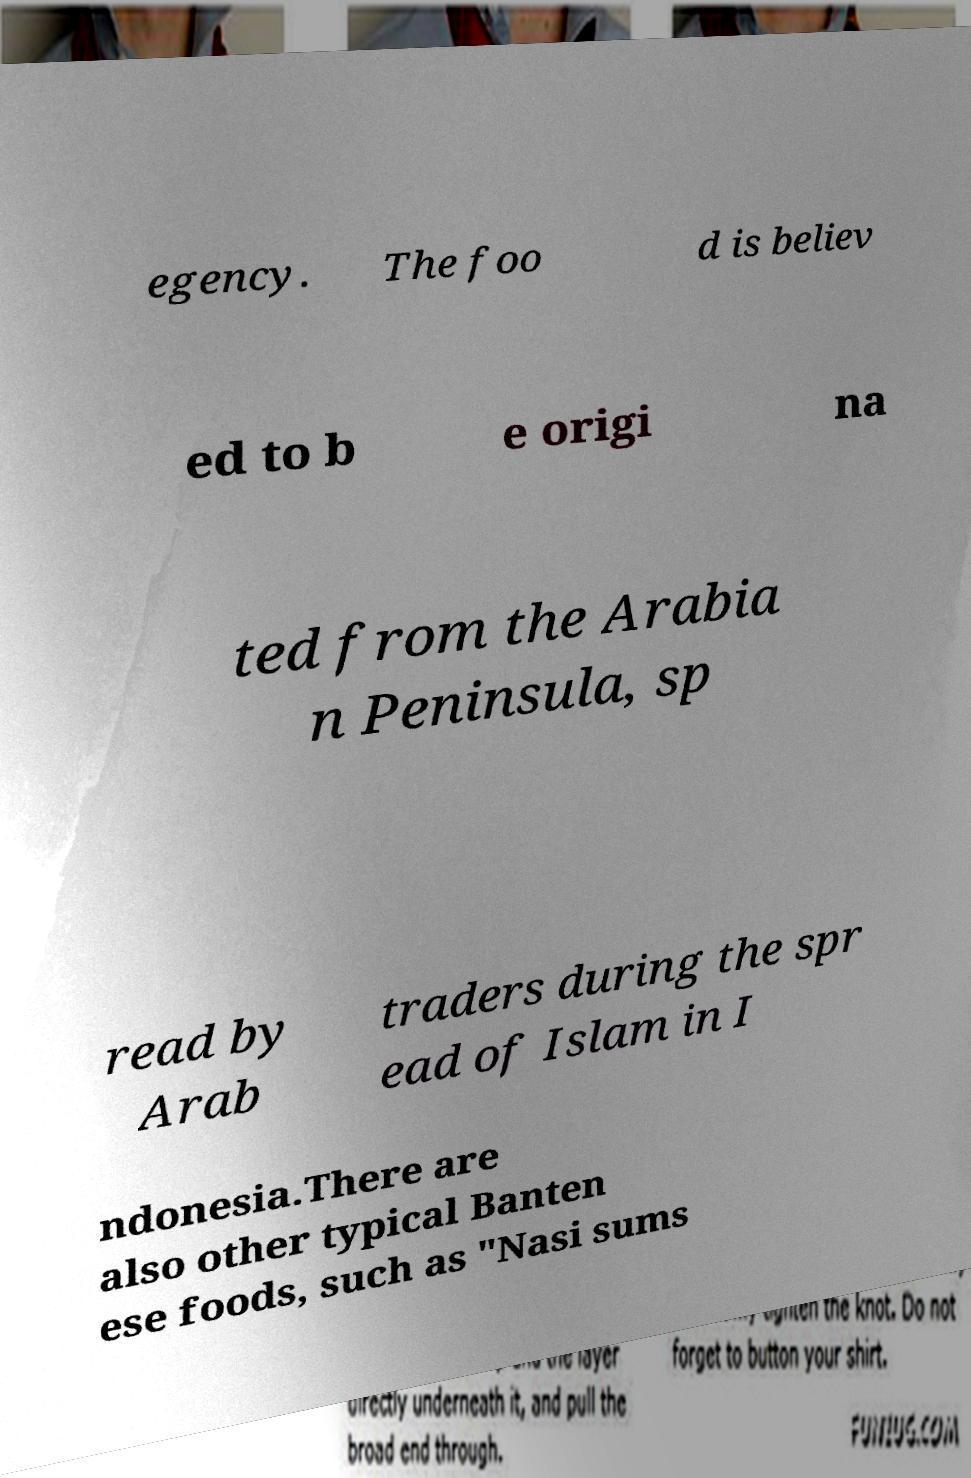Could you extract and type out the text from this image? egency. The foo d is believ ed to b e origi na ted from the Arabia n Peninsula, sp read by Arab traders during the spr ead of Islam in I ndonesia.There are also other typical Banten ese foods, such as "Nasi sums 